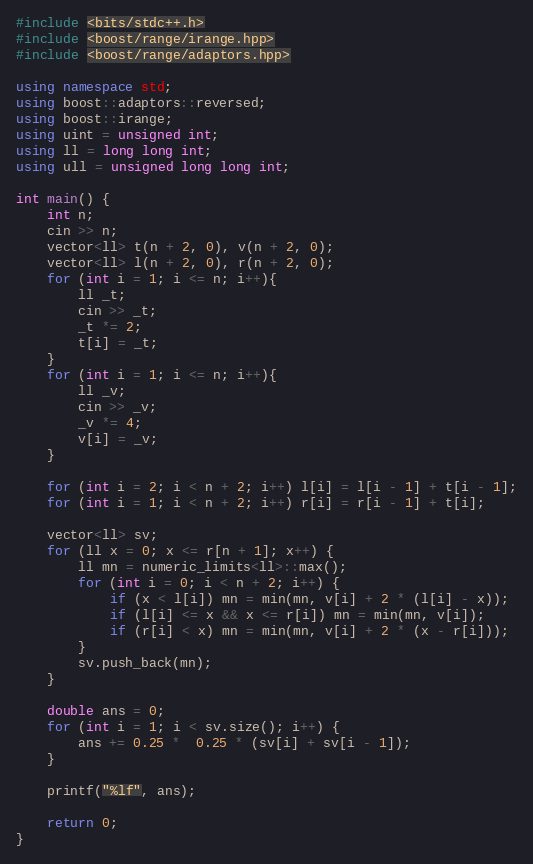Convert code to text. <code><loc_0><loc_0><loc_500><loc_500><_C++_>#include <bits/stdc++.h>
#include <boost/range/irange.hpp>
#include <boost/range/adaptors.hpp>

using namespace std;
using boost::adaptors::reversed;
using boost::irange;
using uint = unsigned int;
using ll = long long int;
using ull = unsigned long long int;

int main() {
    int n;
    cin >> n;
    vector<ll> t(n + 2, 0), v(n + 2, 0);
    vector<ll> l(n + 2, 0), r(n + 2, 0);
    for (int i = 1; i <= n; i++){
        ll _t;
        cin >> _t;
        _t *= 2;
        t[i] = _t;
    }
    for (int i = 1; i <= n; i++){
        ll _v;
        cin >> _v;
        _v *= 4;
        v[i] = _v;
    }

    for (int i = 2; i < n + 2; i++) l[i] = l[i - 1] + t[i - 1];
    for (int i = 1; i < n + 2; i++) r[i] = r[i - 1] + t[i];

    vector<ll> sv;
    for (ll x = 0; x <= r[n + 1]; x++) {
        ll mn = numeric_limits<ll>::max();
        for (int i = 0; i < n + 2; i++) {
            if (x < l[i]) mn = min(mn, v[i] + 2 * (l[i] - x));
            if (l[i] <= x && x <= r[i]) mn = min(mn, v[i]);
            if (r[i] < x) mn = min(mn, v[i] + 2 * (x - r[i]));
        }
        sv.push_back(mn);
    }

    double ans = 0;
    for (int i = 1; i < sv.size(); i++) {
        ans += 0.25 *  0.25 * (sv[i] + sv[i - 1]);
    }

    printf("%lf", ans);

    return 0;
}
</code> 